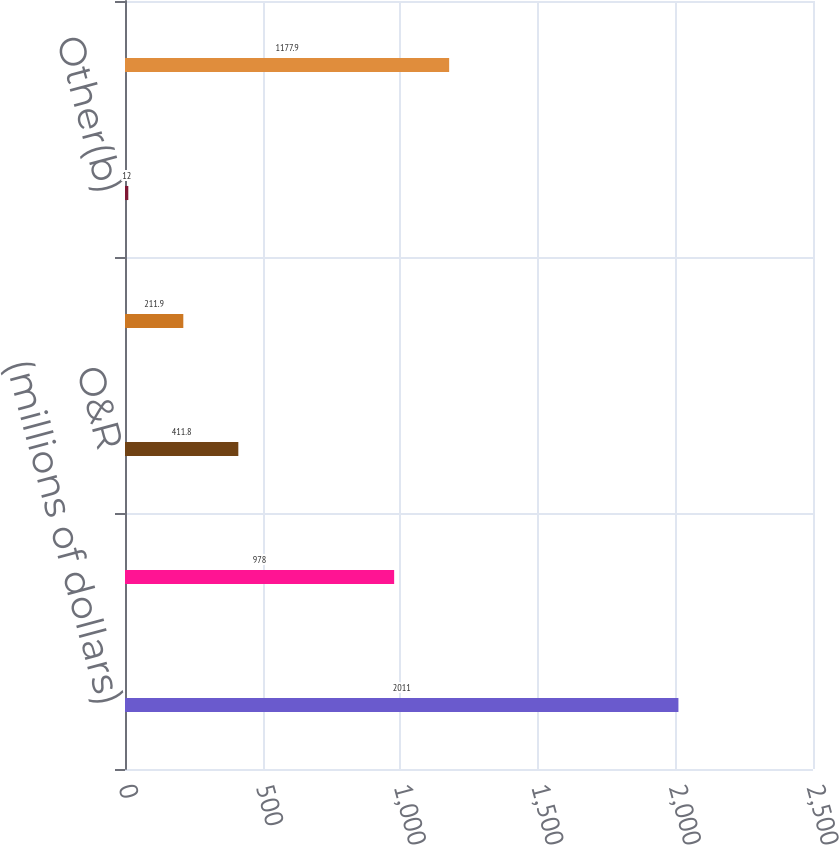<chart> <loc_0><loc_0><loc_500><loc_500><bar_chart><fcel>(millions of dollars)<fcel>CECONY<fcel>O&R<fcel>Competitive energy<fcel>Other(b)<fcel>Con Edison<nl><fcel>2011<fcel>978<fcel>411.8<fcel>211.9<fcel>12<fcel>1177.9<nl></chart> 